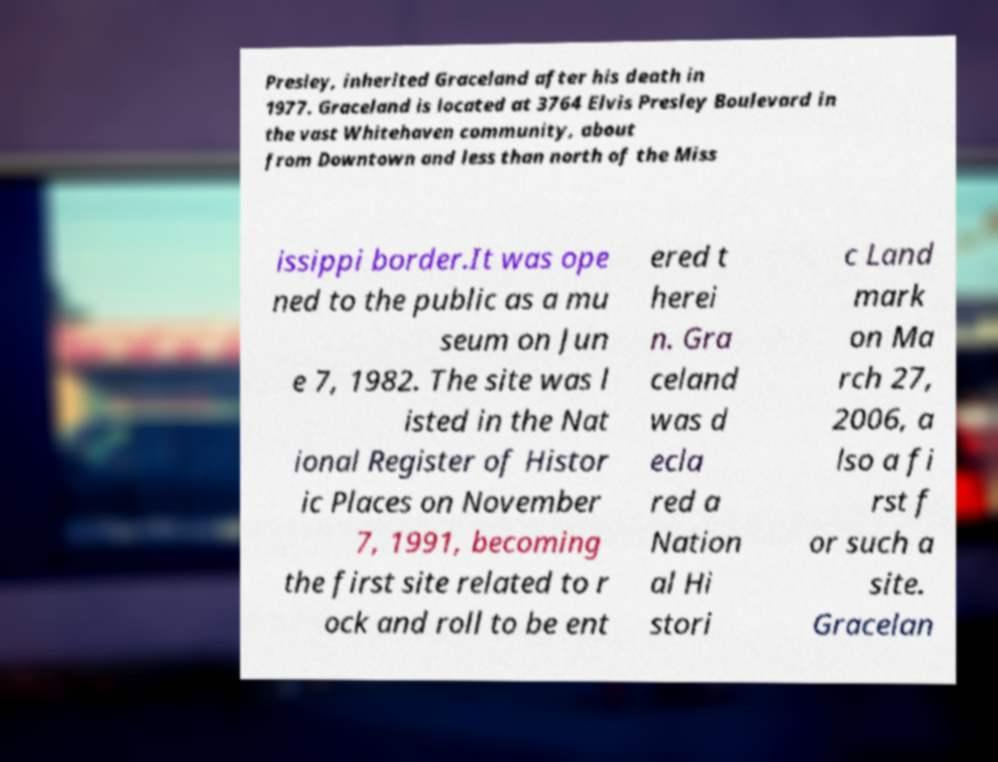What messages or text are displayed in this image? I need them in a readable, typed format. Presley, inherited Graceland after his death in 1977. Graceland is located at 3764 Elvis Presley Boulevard in the vast Whitehaven community, about from Downtown and less than north of the Miss issippi border.It was ope ned to the public as a mu seum on Jun e 7, 1982. The site was l isted in the Nat ional Register of Histor ic Places on November 7, 1991, becoming the first site related to r ock and roll to be ent ered t herei n. Gra celand was d ecla red a Nation al Hi stori c Land mark on Ma rch 27, 2006, a lso a fi rst f or such a site. Gracelan 